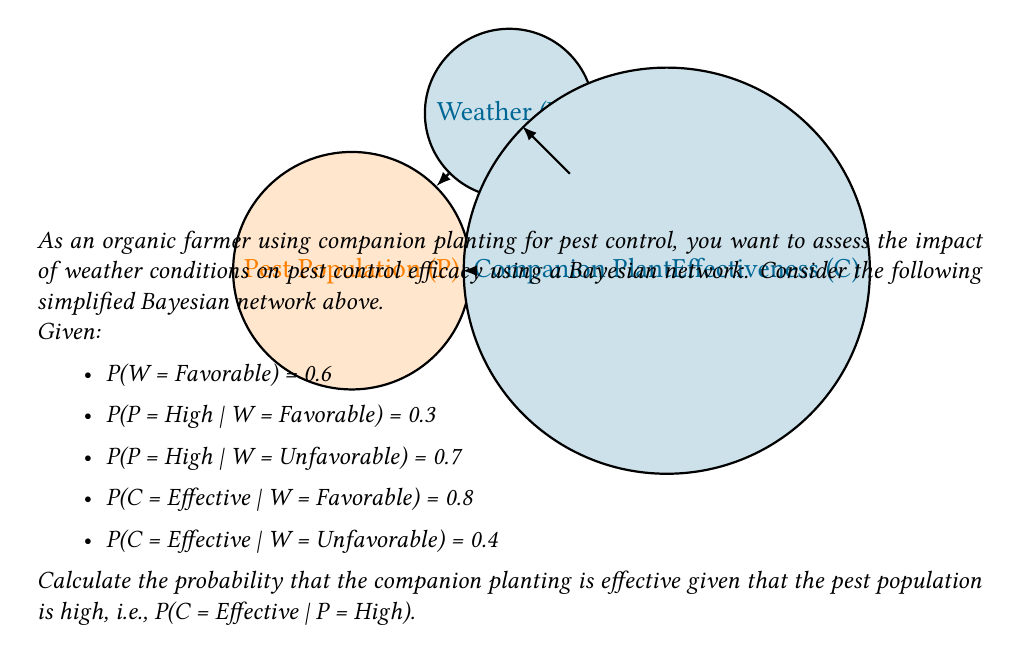Give your solution to this math problem. To solve this problem, we'll use Bayes' theorem and the law of total probability. Let's break it down step-by-step:

1) We want to find P(C = Effective | P = High). Using Bayes' theorem:

   $$P(C = Effective | P = High) = \frac{P(P = High | C = Effective) \cdot P(C = Effective)}{P(P = High)}$$

2) We need to calculate P(C = Effective) and P(P = High) using the law of total probability:

   $$P(C = Effective) = P(C = Effective | W = Favorable) \cdot P(W = Favorable) + P(C = Effective | W = Unfavorable) \cdot P(W = Unfavorable)$$
   $$P(C = Effective) = 0.8 \cdot 0.6 + 0.4 \cdot 0.4 = 0.48 + 0.16 = 0.64$$

   $$P(P = High) = P(P = High | W = Favorable) \cdot P(W = Favorable) + P(P = High | W = Unfavorable) \cdot P(W = Unfavorable)$$
   $$P(P = High) = 0.3 \cdot 0.6 + 0.7 \cdot 0.4 = 0.18 + 0.28 = 0.46$$

3) Now we need to calculate P(P = High | C = Effective):

   $$P(P = High | C = Effective) = \frac{P(P = High, C = Effective)}{P(C = Effective)}$$

4) To find P(P = High, C = Effective), we use the law of total probability again:

   $$P(P = High, C = Effective) = P(P = High, C = Effective | W = Favorable) \cdot P(W = Favorable) + P(P = High, C = Effective | W = Unfavorable) \cdot P(W = Unfavorable)$$

   Assuming independence of P and C given W:
   $$P(P = High, C = Effective | W = Favorable) = P(P = High | W = Favorable) \cdot P(C = Effective | W = Favorable) = 0.3 \cdot 0.8 = 0.24$$
   $$P(P = High, C = Effective | W = Unfavorable) = P(P = High | W = Unfavorable) \cdot P(C = Effective | W = Unfavorable) = 0.7 \cdot 0.4 = 0.28$$

   $$P(P = High, C = Effective) = 0.24 \cdot 0.6 + 0.28 \cdot 0.4 = 0.144 + 0.112 = 0.256$$

5) Now we can calculate P(P = High | C = Effective):

   $$P(P = High | C = Effective) = \frac{0.256}{0.64} = 0.4$$

6) Finally, we can plug everything into Bayes' theorem:

   $$P(C = Effective | P = High) = \frac{0.4 \cdot 0.64}{0.46} \approx 0.5565$$
Answer: $P(C = Effective | P = High) \approx 0.5565$ or about 55.65% 